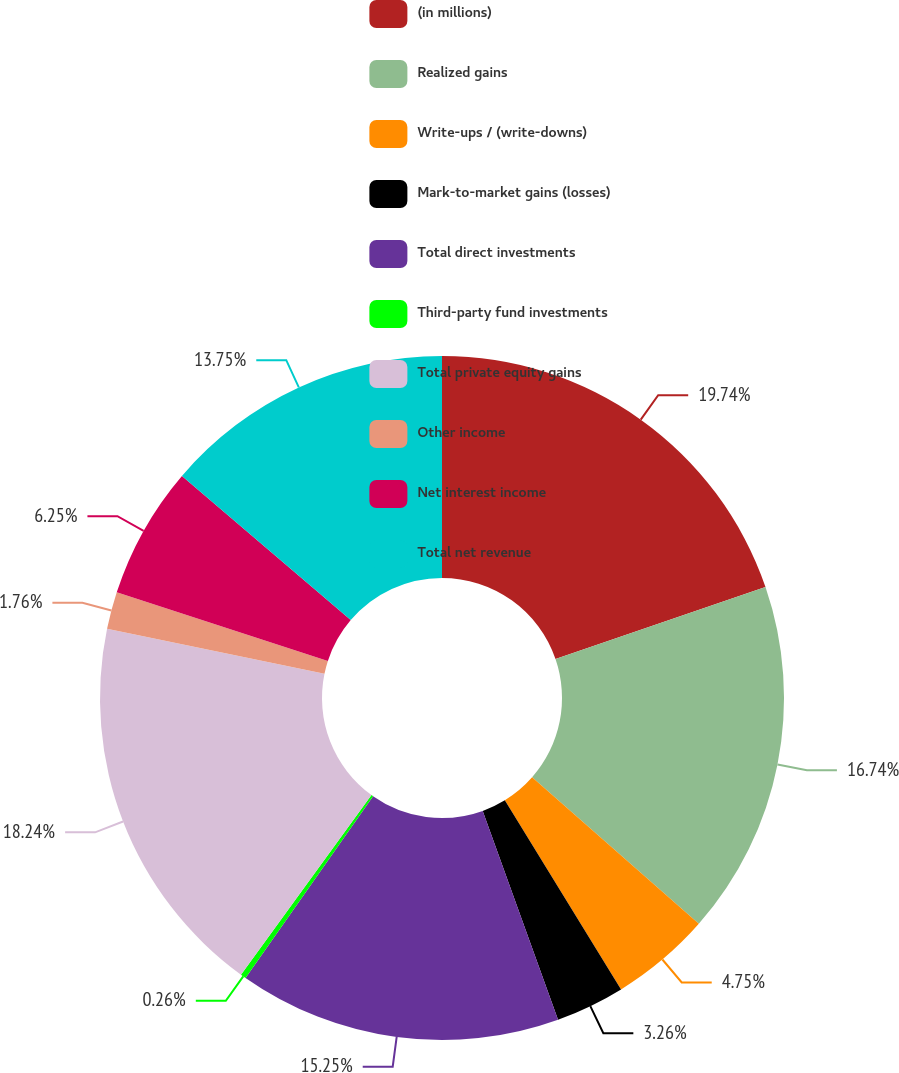Convert chart. <chart><loc_0><loc_0><loc_500><loc_500><pie_chart><fcel>(in millions)<fcel>Realized gains<fcel>Write-ups / (write-downs)<fcel>Mark-to-market gains (losses)<fcel>Total direct investments<fcel>Third-party fund investments<fcel>Total private equity gains<fcel>Other income<fcel>Net interest income<fcel>Total net revenue<nl><fcel>19.74%<fcel>16.74%<fcel>4.75%<fcel>3.26%<fcel>15.25%<fcel>0.26%<fcel>18.24%<fcel>1.76%<fcel>6.25%<fcel>13.75%<nl></chart> 